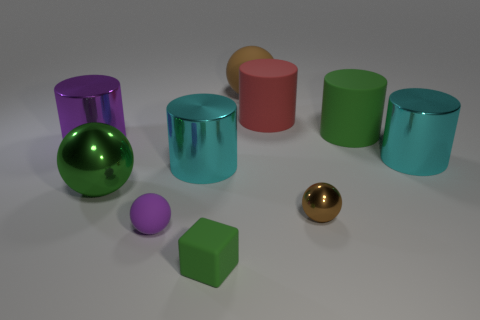There is a brown thing that is in front of the purple cylinder; what is its shape?
Offer a terse response. Sphere. Are the large sphere on the left side of the tiny green cube and the big thing on the left side of the green metal ball made of the same material?
Your answer should be compact. Yes. Are there any other large shiny objects of the same shape as the big brown object?
Give a very brief answer. Yes. How many objects are either small spheres that are on the right side of the purple rubber thing or large metallic cylinders?
Offer a very short reply. 4. Are there more big cyan cylinders to the right of the brown matte thing than tiny shiny spheres to the right of the big green matte cylinder?
Ensure brevity in your answer.  Yes. How many metal things are small brown things or purple objects?
Your response must be concise. 2. What material is the sphere that is the same color as the matte cube?
Make the answer very short. Metal. Are there fewer small blocks to the left of the large metallic ball than things that are behind the large red matte thing?
Offer a terse response. Yes. How many things are big blue matte cylinders or metallic balls that are on the left side of the rubber block?
Your response must be concise. 1. What material is the red cylinder that is the same size as the green sphere?
Ensure brevity in your answer.  Rubber. 